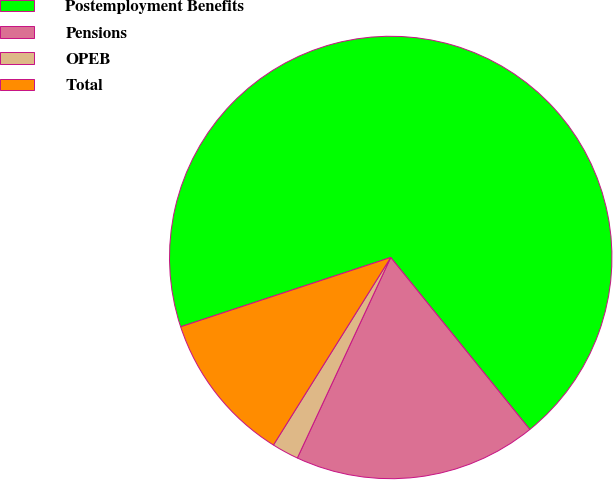Convert chart to OTSL. <chart><loc_0><loc_0><loc_500><loc_500><pie_chart><fcel>Postemployment Benefits<fcel>Pensions<fcel>OPEB<fcel>Total<nl><fcel>69.25%<fcel>17.76%<fcel>1.96%<fcel>11.03%<nl></chart> 